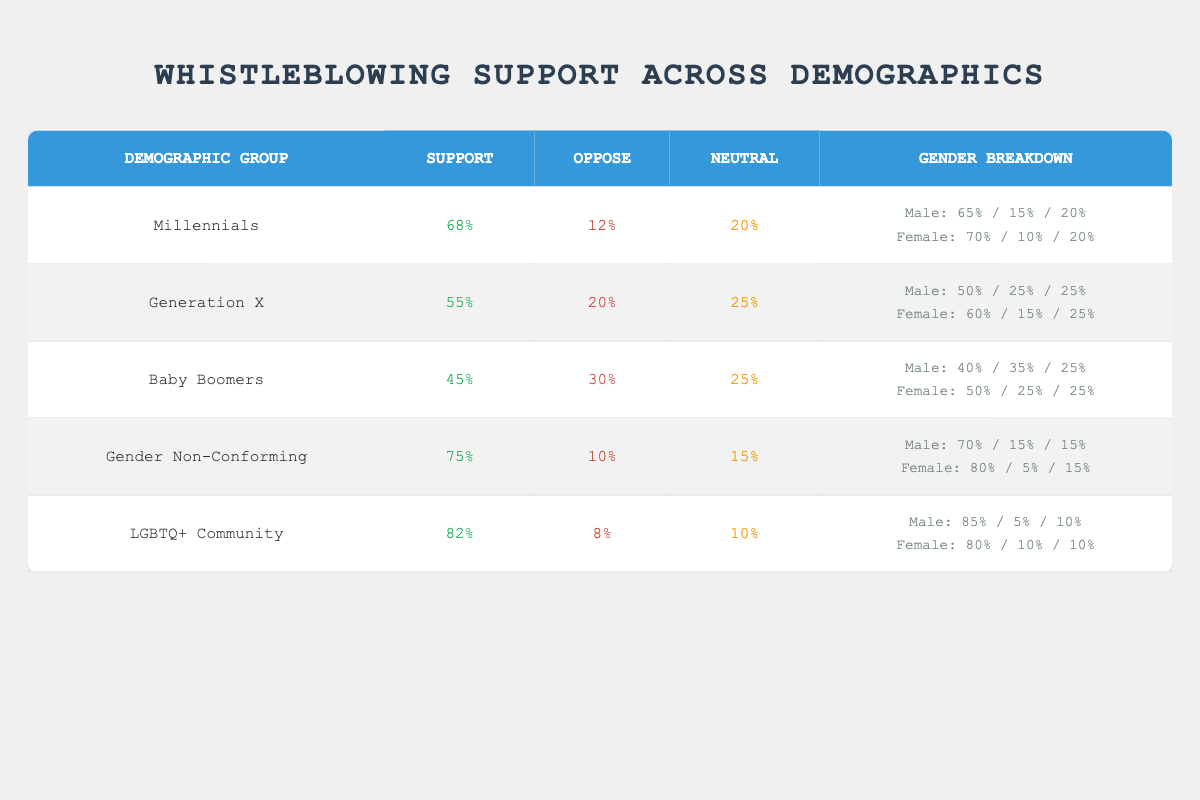What percentage of Millennials support whistleblowing? The table shows that Millennials have a support percentage of 68%.
Answer: 68% Which demographic group has the highest percentage of oppose in whistleblowing support? The table indicates that Baby Boomers have the highest oppose percentage at 30%.
Answer: 30% What is the average support percentage across all demographic groups? The support percentages for all groups are 68, 55, 45, 75, and 82. The total is 68 + 55 + 45 + 75 + 82 = 325. There are 5 groups, so the average is 325/5 = 65.
Answer: 65 Do more than 80% of the LGBTQ+ Community support whistleblowing? The table states that 82% of the LGBTQ+ Community supports whistleblowing, which is greater than 80%.
Answer: Yes What is the difference in support percentage between Gender Non-Conforming individuals and Baby Boomers? The support percentage for Gender Non-Conforming is 75% and for Baby Boomers is 45%. The difference is 75 - 45 = 30.
Answer: 30 